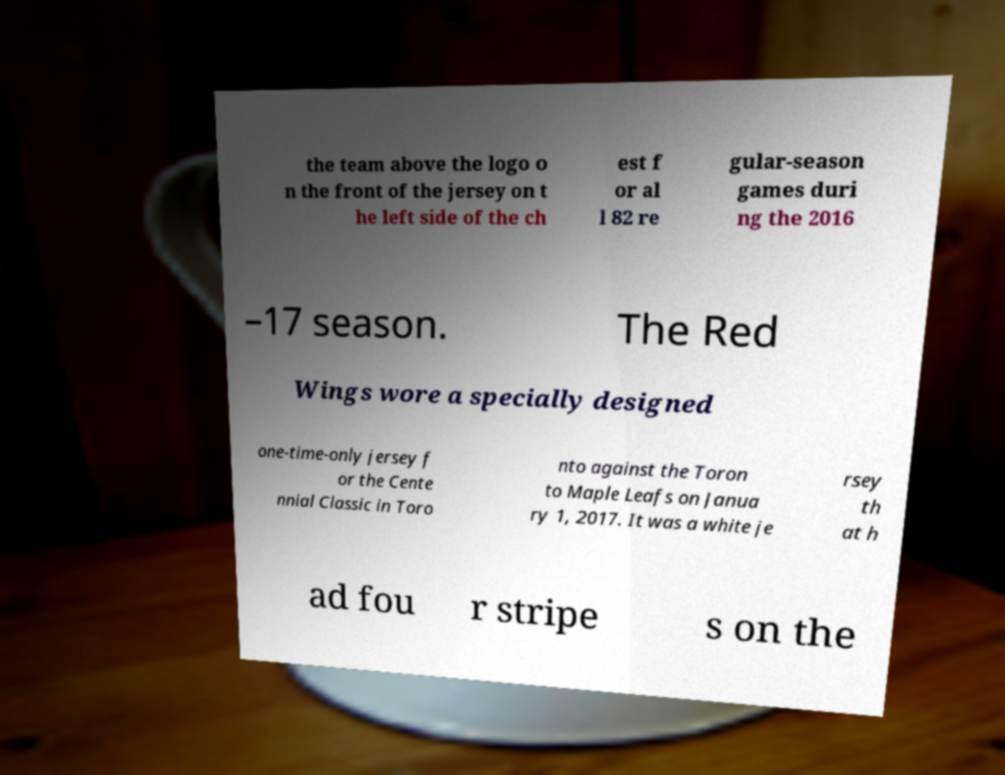Please read and relay the text visible in this image. What does it say? the team above the logo o n the front of the jersey on t he left side of the ch est f or al l 82 re gular-season games duri ng the 2016 –17 season. The Red Wings wore a specially designed one-time-only jersey f or the Cente nnial Classic in Toro nto against the Toron to Maple Leafs on Janua ry 1, 2017. It was a white je rsey th at h ad fou r stripe s on the 